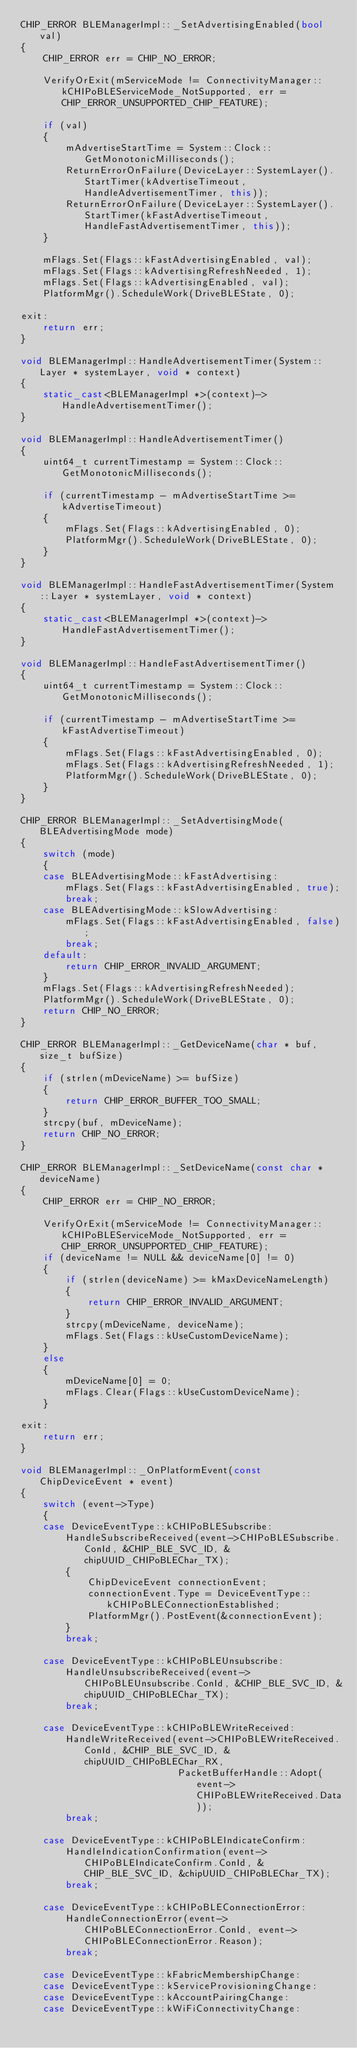<code> <loc_0><loc_0><loc_500><loc_500><_C++_>CHIP_ERROR BLEManagerImpl::_SetAdvertisingEnabled(bool val)
{
    CHIP_ERROR err = CHIP_NO_ERROR;

    VerifyOrExit(mServiceMode != ConnectivityManager::kCHIPoBLEServiceMode_NotSupported, err = CHIP_ERROR_UNSUPPORTED_CHIP_FEATURE);

    if (val)
    {
        mAdvertiseStartTime = System::Clock::GetMonotonicMilliseconds();
        ReturnErrorOnFailure(DeviceLayer::SystemLayer().StartTimer(kAdvertiseTimeout, HandleAdvertisementTimer, this));
        ReturnErrorOnFailure(DeviceLayer::SystemLayer().StartTimer(kFastAdvertiseTimeout, HandleFastAdvertisementTimer, this));
    }

    mFlags.Set(Flags::kFastAdvertisingEnabled, val);
    mFlags.Set(Flags::kAdvertisingRefreshNeeded, 1);
    mFlags.Set(Flags::kAdvertisingEnabled, val);
    PlatformMgr().ScheduleWork(DriveBLEState, 0);

exit:
    return err;
}

void BLEManagerImpl::HandleAdvertisementTimer(System::Layer * systemLayer, void * context)
{
    static_cast<BLEManagerImpl *>(context)->HandleAdvertisementTimer();
}

void BLEManagerImpl::HandleAdvertisementTimer()
{
    uint64_t currentTimestamp = System::Clock::GetMonotonicMilliseconds();

    if (currentTimestamp - mAdvertiseStartTime >= kAdvertiseTimeout)
    {
        mFlags.Set(Flags::kAdvertisingEnabled, 0);
        PlatformMgr().ScheduleWork(DriveBLEState, 0);
    }
}

void BLEManagerImpl::HandleFastAdvertisementTimer(System::Layer * systemLayer, void * context)
{
    static_cast<BLEManagerImpl *>(context)->HandleFastAdvertisementTimer();
}

void BLEManagerImpl::HandleFastAdvertisementTimer()
{
    uint64_t currentTimestamp = System::Clock::GetMonotonicMilliseconds();

    if (currentTimestamp - mAdvertiseStartTime >= kFastAdvertiseTimeout)
    {
        mFlags.Set(Flags::kFastAdvertisingEnabled, 0);
        mFlags.Set(Flags::kAdvertisingRefreshNeeded, 1);
        PlatformMgr().ScheduleWork(DriveBLEState, 0);
    }
}

CHIP_ERROR BLEManagerImpl::_SetAdvertisingMode(BLEAdvertisingMode mode)
{
    switch (mode)
    {
    case BLEAdvertisingMode::kFastAdvertising:
        mFlags.Set(Flags::kFastAdvertisingEnabled, true);
        break;
    case BLEAdvertisingMode::kSlowAdvertising:
        mFlags.Set(Flags::kFastAdvertisingEnabled, false);
        break;
    default:
        return CHIP_ERROR_INVALID_ARGUMENT;
    }
    mFlags.Set(Flags::kAdvertisingRefreshNeeded);
    PlatformMgr().ScheduleWork(DriveBLEState, 0);
    return CHIP_NO_ERROR;
}

CHIP_ERROR BLEManagerImpl::_GetDeviceName(char * buf, size_t bufSize)
{
    if (strlen(mDeviceName) >= bufSize)
    {
        return CHIP_ERROR_BUFFER_TOO_SMALL;
    }
    strcpy(buf, mDeviceName);
    return CHIP_NO_ERROR;
}

CHIP_ERROR BLEManagerImpl::_SetDeviceName(const char * deviceName)
{
    CHIP_ERROR err = CHIP_NO_ERROR;

    VerifyOrExit(mServiceMode != ConnectivityManager::kCHIPoBLEServiceMode_NotSupported, err = CHIP_ERROR_UNSUPPORTED_CHIP_FEATURE);
    if (deviceName != NULL && deviceName[0] != 0)
    {
        if (strlen(deviceName) >= kMaxDeviceNameLength)
        {
            return CHIP_ERROR_INVALID_ARGUMENT;
        }
        strcpy(mDeviceName, deviceName);
        mFlags.Set(Flags::kUseCustomDeviceName);
    }
    else
    {
        mDeviceName[0] = 0;
        mFlags.Clear(Flags::kUseCustomDeviceName);
    }

exit:
    return err;
}

void BLEManagerImpl::_OnPlatformEvent(const ChipDeviceEvent * event)
{
    switch (event->Type)
    {
    case DeviceEventType::kCHIPoBLESubscribe:
        HandleSubscribeReceived(event->CHIPoBLESubscribe.ConId, &CHIP_BLE_SVC_ID, &chipUUID_CHIPoBLEChar_TX);
        {
            ChipDeviceEvent connectionEvent;
            connectionEvent.Type = DeviceEventType::kCHIPoBLEConnectionEstablished;
            PlatformMgr().PostEvent(&connectionEvent);
        }
        break;

    case DeviceEventType::kCHIPoBLEUnsubscribe:
        HandleUnsubscribeReceived(event->CHIPoBLEUnsubscribe.ConId, &CHIP_BLE_SVC_ID, &chipUUID_CHIPoBLEChar_TX);
        break;

    case DeviceEventType::kCHIPoBLEWriteReceived:
        HandleWriteReceived(event->CHIPoBLEWriteReceived.ConId, &CHIP_BLE_SVC_ID, &chipUUID_CHIPoBLEChar_RX,
                            PacketBufferHandle::Adopt(event->CHIPoBLEWriteReceived.Data));
        break;

    case DeviceEventType::kCHIPoBLEIndicateConfirm:
        HandleIndicationConfirmation(event->CHIPoBLEIndicateConfirm.ConId, &CHIP_BLE_SVC_ID, &chipUUID_CHIPoBLEChar_TX);
        break;

    case DeviceEventType::kCHIPoBLEConnectionError:
        HandleConnectionError(event->CHIPoBLEConnectionError.ConId, event->CHIPoBLEConnectionError.Reason);
        break;

    case DeviceEventType::kFabricMembershipChange:
    case DeviceEventType::kServiceProvisioningChange:
    case DeviceEventType::kAccountPairingChange:
    case DeviceEventType::kWiFiConnectivityChange:
</code> 